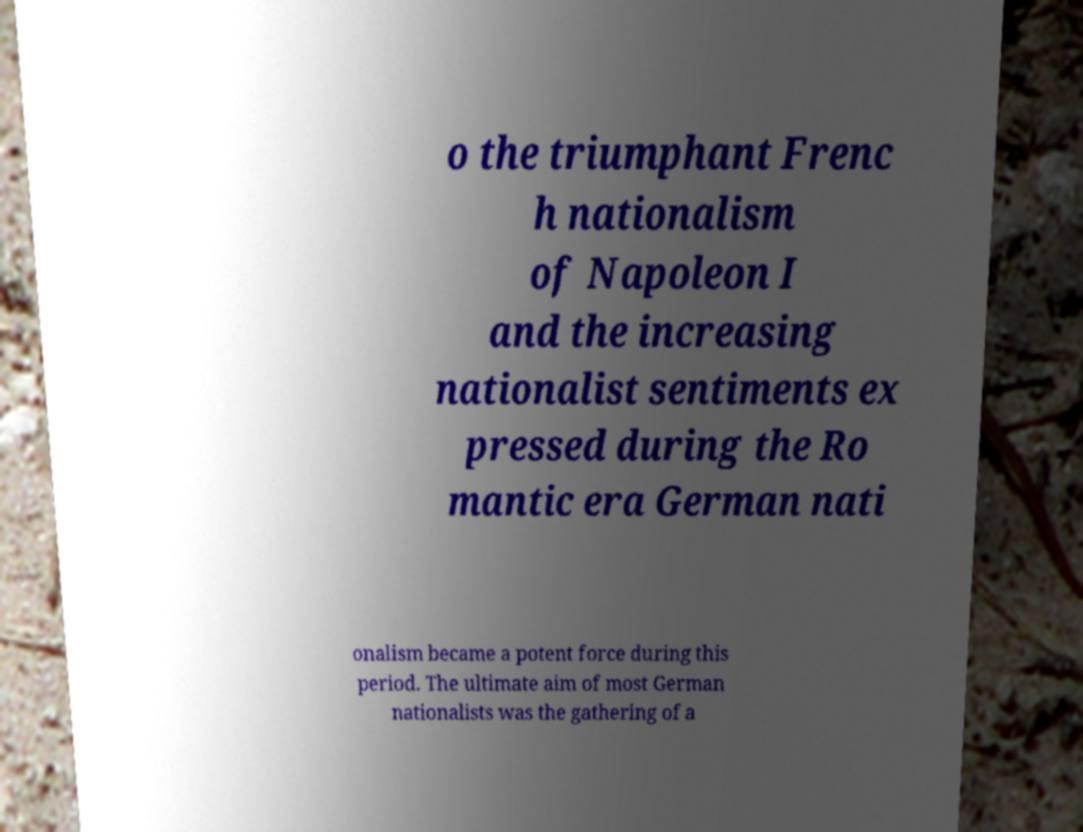What messages or text are displayed in this image? I need them in a readable, typed format. o the triumphant Frenc h nationalism of Napoleon I and the increasing nationalist sentiments ex pressed during the Ro mantic era German nati onalism became a potent force during this period. The ultimate aim of most German nationalists was the gathering of a 